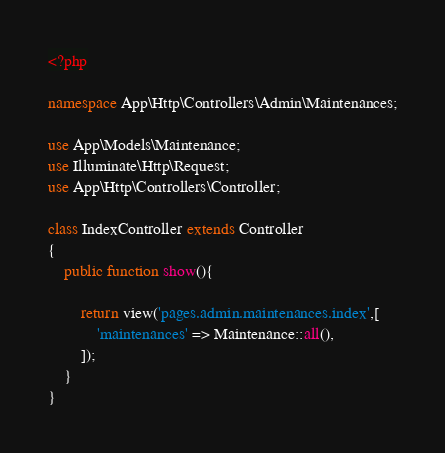Convert code to text. <code><loc_0><loc_0><loc_500><loc_500><_PHP_><?php

namespace App\Http\Controllers\Admin\Maintenances;

use App\Models\Maintenance;
use Illuminate\Http\Request;
use App\Http\Controllers\Controller;

class IndexController extends Controller
{
    public function show(){

        return view('pages.admin.maintenances.index',[
            'maintenances' => Maintenance::all(),
        ]);
    }
}
</code> 